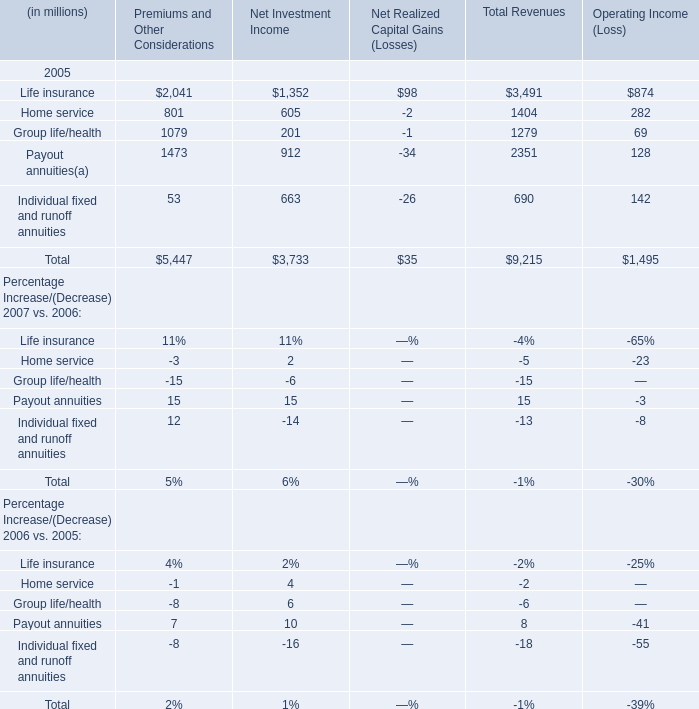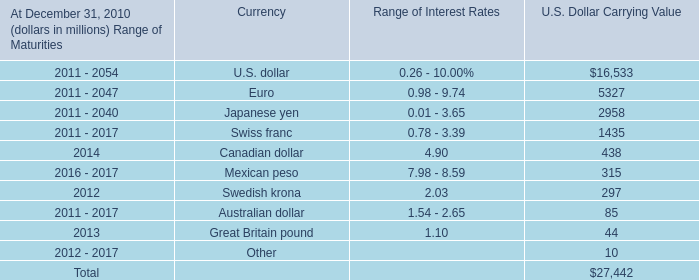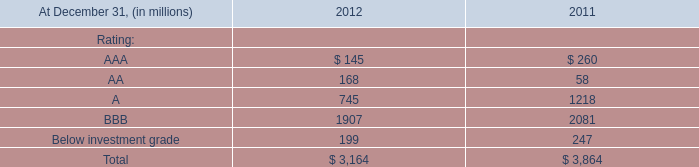What was the average value of the Home service in the year where Life insurance is positive? (in million) 
Computations: ((((801 + 605) - 2) + 282) / 1)
Answer: 1686.0. 